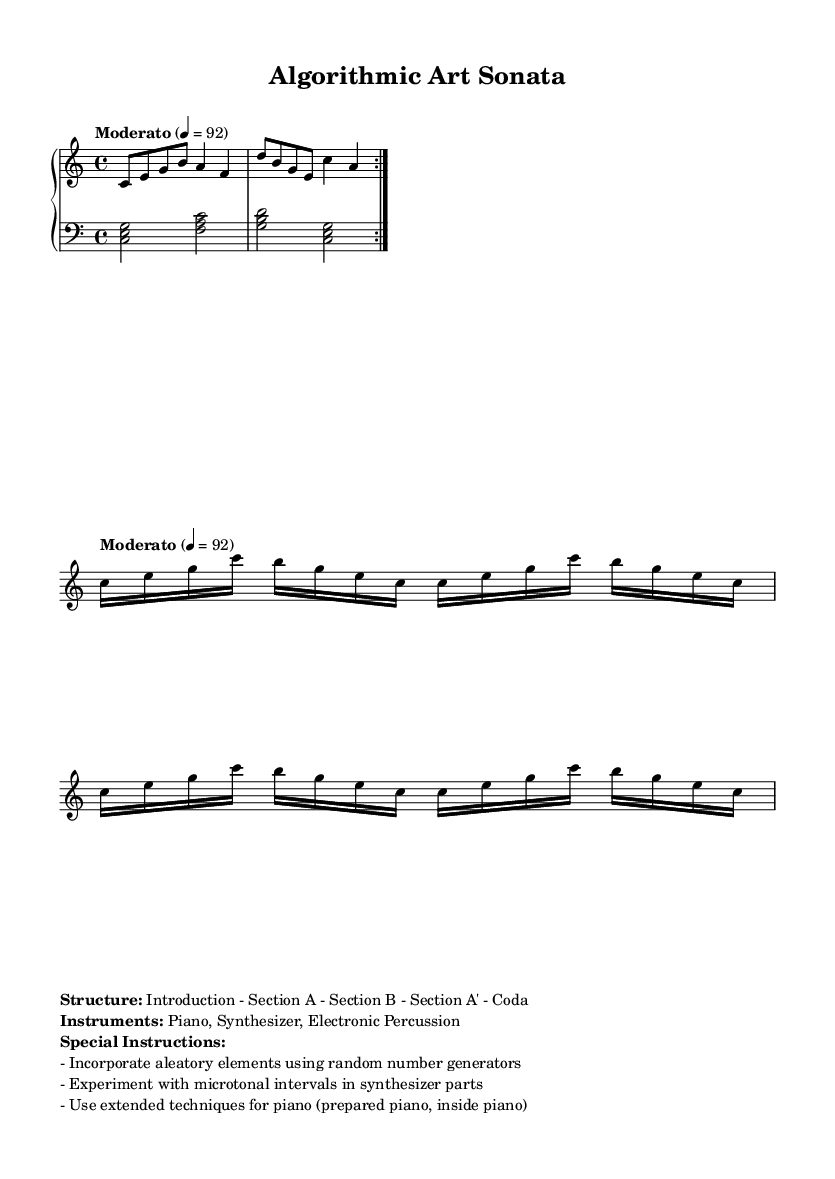What is the key signature of this music? The key signature is indicated by the absence of sharps or flats at the beginning of the staff, which corresponds to C major.
Answer: C major What is the time signature of this piece? The time signature is found at the beginning of the staff, shown as 4/4, indicating four beats per measure.
Answer: 4/4 What is the tempo marking for this music? The tempo marking is written as "Moderato," with a metronome marking of quarter note equals 92.
Answer: Moderato How many times is Section A repeated? Section A is repeated twice as indicated by the repeat volta marking (two dots) in the sheet music.
Answer: 2 What instruments are used in this composition? The instruments are listed in the markup section, detailing Piano, Synthesizer, and Electronic Percussion.
Answer: Piano, Synthesizer, Electronic Percussion What is a special instruction given for the synthesizer parts? The special instruction mentions experimenting with microtonal intervals specifically within the synthesizer parts provided.
Answer: Microtonal intervals What type of elements are suggested to be incorporated into the piece? The instructions suggest incorporating aleatory elements through the use of random number generators, allowing for chance and unpredictability.
Answer: Aleatory elements 